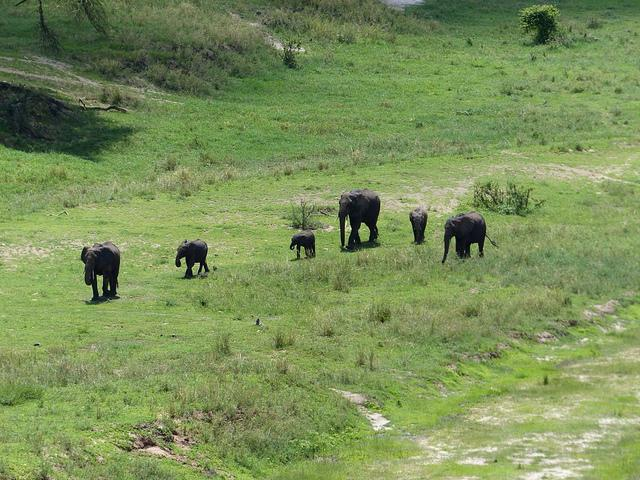What is the littlest elephant called? Please explain your reasoning. calf. A young one of an elephant is called a calf. 